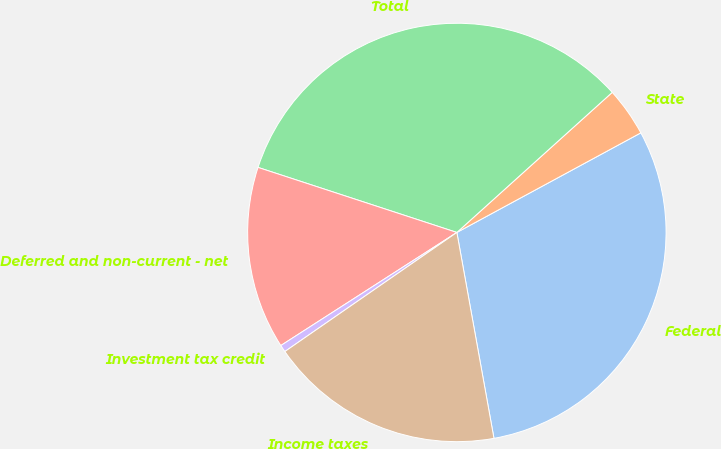Convert chart. <chart><loc_0><loc_0><loc_500><loc_500><pie_chart><fcel>Federal<fcel>State<fcel>Total<fcel>Deferred and non-current - net<fcel>Investment tax credit<fcel>Income taxes<nl><fcel>30.06%<fcel>3.78%<fcel>33.29%<fcel>14.12%<fcel>0.55%<fcel>18.2%<nl></chart> 